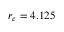Convert formula to latex. <formula><loc_0><loc_0><loc_500><loc_500>r _ { c } = 4 . 1 2 5</formula> 